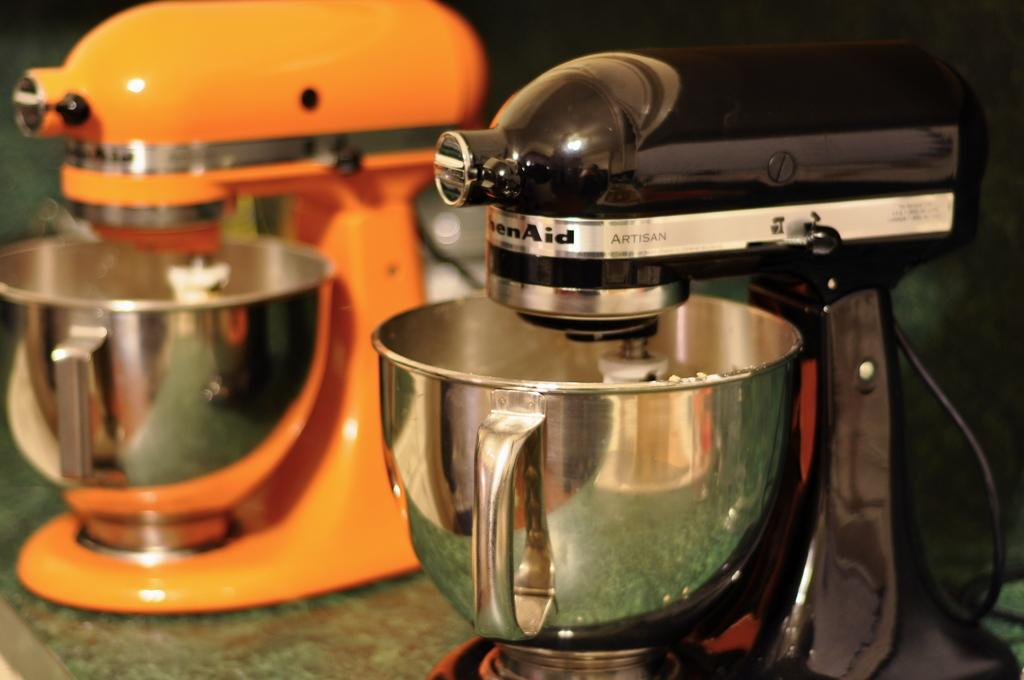<image>
Give a short and clear explanation of the subsequent image. One black and one orange Kitchen Aid stand mixers. 